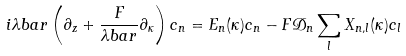Convert formula to latex. <formula><loc_0><loc_0><loc_500><loc_500>i \lambda b a r \left ( \partial _ { z } + \frac { F } { \lambda b a r } \partial _ { \kappa } \right ) c _ { n } = E _ { n } ( \kappa ) c _ { n } - F \mathcal { D } _ { n } \sum _ { l } X _ { n , l } ( \kappa ) c _ { l }</formula> 